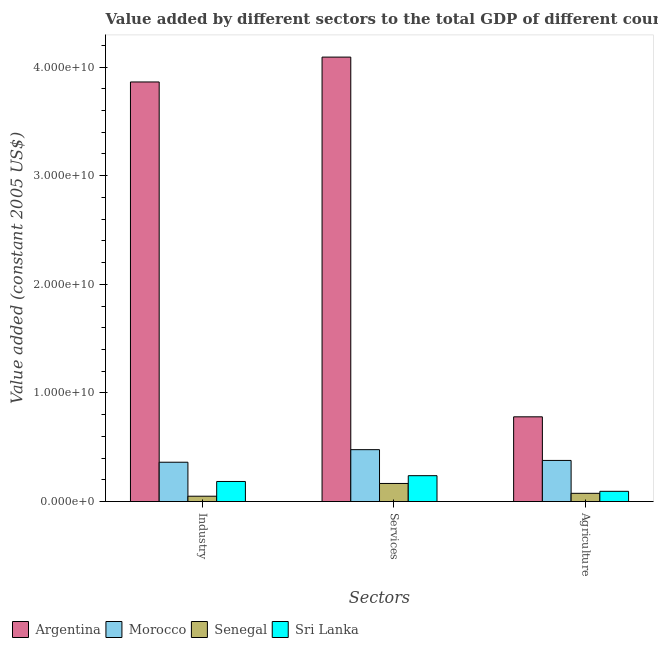What is the label of the 1st group of bars from the left?
Offer a very short reply. Industry. What is the value added by services in Senegal?
Give a very brief answer. 1.67e+09. Across all countries, what is the maximum value added by agricultural sector?
Your response must be concise. 7.80e+09. Across all countries, what is the minimum value added by agricultural sector?
Your answer should be very brief. 7.59e+08. In which country was the value added by agricultural sector minimum?
Provide a succinct answer. Senegal. What is the total value added by industrial sector in the graph?
Provide a succinct answer. 4.46e+1. What is the difference between the value added by industrial sector in Senegal and that in Sri Lanka?
Give a very brief answer. -1.36e+09. What is the difference between the value added by services in Argentina and the value added by agricultural sector in Morocco?
Ensure brevity in your answer.  3.71e+1. What is the average value added by industrial sector per country?
Provide a succinct answer. 1.11e+1. What is the difference between the value added by industrial sector and value added by agricultural sector in Morocco?
Offer a very short reply. -1.65e+08. In how many countries, is the value added by services greater than 18000000000 US$?
Your response must be concise. 1. What is the ratio of the value added by services in Senegal to that in Morocco?
Ensure brevity in your answer.  0.35. Is the value added by services in Morocco less than that in Argentina?
Your answer should be very brief. Yes. What is the difference between the highest and the second highest value added by industrial sector?
Your answer should be very brief. 3.50e+1. What is the difference between the highest and the lowest value added by agricultural sector?
Your response must be concise. 7.04e+09. In how many countries, is the value added by agricultural sector greater than the average value added by agricultural sector taken over all countries?
Ensure brevity in your answer.  2. Is the sum of the value added by industrial sector in Morocco and Sri Lanka greater than the maximum value added by agricultural sector across all countries?
Ensure brevity in your answer.  No. What does the 2nd bar from the left in Industry represents?
Make the answer very short. Morocco. What does the 3rd bar from the right in Agriculture represents?
Provide a short and direct response. Morocco. Is it the case that in every country, the sum of the value added by industrial sector and value added by services is greater than the value added by agricultural sector?
Give a very brief answer. Yes. Are all the bars in the graph horizontal?
Your answer should be very brief. No. How many countries are there in the graph?
Your answer should be compact. 4. What is the difference between two consecutive major ticks on the Y-axis?
Your response must be concise. 1.00e+1. Does the graph contain any zero values?
Ensure brevity in your answer.  No. How many legend labels are there?
Offer a terse response. 4. How are the legend labels stacked?
Ensure brevity in your answer.  Horizontal. What is the title of the graph?
Provide a succinct answer. Value added by different sectors to the total GDP of different countries. What is the label or title of the X-axis?
Offer a very short reply. Sectors. What is the label or title of the Y-axis?
Provide a succinct answer. Value added (constant 2005 US$). What is the Value added (constant 2005 US$) in Argentina in Industry?
Your answer should be very brief. 3.86e+1. What is the Value added (constant 2005 US$) of Morocco in Industry?
Make the answer very short. 3.62e+09. What is the Value added (constant 2005 US$) of Senegal in Industry?
Offer a very short reply. 4.93e+08. What is the Value added (constant 2005 US$) in Sri Lanka in Industry?
Your answer should be very brief. 1.85e+09. What is the Value added (constant 2005 US$) of Argentina in Services?
Provide a short and direct response. 4.09e+1. What is the Value added (constant 2005 US$) in Morocco in Services?
Make the answer very short. 4.78e+09. What is the Value added (constant 2005 US$) in Senegal in Services?
Make the answer very short. 1.67e+09. What is the Value added (constant 2005 US$) of Sri Lanka in Services?
Your answer should be very brief. 2.38e+09. What is the Value added (constant 2005 US$) of Argentina in Agriculture?
Offer a terse response. 7.80e+09. What is the Value added (constant 2005 US$) of Morocco in Agriculture?
Offer a terse response. 3.79e+09. What is the Value added (constant 2005 US$) of Senegal in Agriculture?
Provide a short and direct response. 7.59e+08. What is the Value added (constant 2005 US$) of Sri Lanka in Agriculture?
Make the answer very short. 9.42e+08. Across all Sectors, what is the maximum Value added (constant 2005 US$) in Argentina?
Provide a succinct answer. 4.09e+1. Across all Sectors, what is the maximum Value added (constant 2005 US$) of Morocco?
Provide a short and direct response. 4.78e+09. Across all Sectors, what is the maximum Value added (constant 2005 US$) in Senegal?
Ensure brevity in your answer.  1.67e+09. Across all Sectors, what is the maximum Value added (constant 2005 US$) in Sri Lanka?
Provide a short and direct response. 2.38e+09. Across all Sectors, what is the minimum Value added (constant 2005 US$) of Argentina?
Offer a terse response. 7.80e+09. Across all Sectors, what is the minimum Value added (constant 2005 US$) in Morocco?
Offer a very short reply. 3.62e+09. Across all Sectors, what is the minimum Value added (constant 2005 US$) of Senegal?
Ensure brevity in your answer.  4.93e+08. Across all Sectors, what is the minimum Value added (constant 2005 US$) in Sri Lanka?
Keep it short and to the point. 9.42e+08. What is the total Value added (constant 2005 US$) of Argentina in the graph?
Your answer should be compact. 8.74e+1. What is the total Value added (constant 2005 US$) in Morocco in the graph?
Ensure brevity in your answer.  1.22e+1. What is the total Value added (constant 2005 US$) of Senegal in the graph?
Ensure brevity in your answer.  2.92e+09. What is the total Value added (constant 2005 US$) of Sri Lanka in the graph?
Keep it short and to the point. 5.18e+09. What is the difference between the Value added (constant 2005 US$) of Argentina in Industry and that in Services?
Your answer should be very brief. -2.29e+09. What is the difference between the Value added (constant 2005 US$) in Morocco in Industry and that in Services?
Ensure brevity in your answer.  -1.16e+09. What is the difference between the Value added (constant 2005 US$) of Senegal in Industry and that in Services?
Your answer should be compact. -1.17e+09. What is the difference between the Value added (constant 2005 US$) of Sri Lanka in Industry and that in Services?
Ensure brevity in your answer.  -5.33e+08. What is the difference between the Value added (constant 2005 US$) in Argentina in Industry and that in Agriculture?
Make the answer very short. 3.08e+1. What is the difference between the Value added (constant 2005 US$) in Morocco in Industry and that in Agriculture?
Ensure brevity in your answer.  -1.65e+08. What is the difference between the Value added (constant 2005 US$) of Senegal in Industry and that in Agriculture?
Your answer should be compact. -2.66e+08. What is the difference between the Value added (constant 2005 US$) in Sri Lanka in Industry and that in Agriculture?
Give a very brief answer. 9.07e+08. What is the difference between the Value added (constant 2005 US$) of Argentina in Services and that in Agriculture?
Your response must be concise. 3.31e+1. What is the difference between the Value added (constant 2005 US$) in Morocco in Services and that in Agriculture?
Provide a short and direct response. 9.91e+08. What is the difference between the Value added (constant 2005 US$) of Senegal in Services and that in Agriculture?
Keep it short and to the point. 9.08e+08. What is the difference between the Value added (constant 2005 US$) in Sri Lanka in Services and that in Agriculture?
Provide a short and direct response. 1.44e+09. What is the difference between the Value added (constant 2005 US$) in Argentina in Industry and the Value added (constant 2005 US$) in Morocco in Services?
Provide a short and direct response. 3.39e+1. What is the difference between the Value added (constant 2005 US$) in Argentina in Industry and the Value added (constant 2005 US$) in Senegal in Services?
Give a very brief answer. 3.70e+1. What is the difference between the Value added (constant 2005 US$) of Argentina in Industry and the Value added (constant 2005 US$) of Sri Lanka in Services?
Make the answer very short. 3.62e+1. What is the difference between the Value added (constant 2005 US$) in Morocco in Industry and the Value added (constant 2005 US$) in Senegal in Services?
Make the answer very short. 1.95e+09. What is the difference between the Value added (constant 2005 US$) of Morocco in Industry and the Value added (constant 2005 US$) of Sri Lanka in Services?
Provide a short and direct response. 1.24e+09. What is the difference between the Value added (constant 2005 US$) of Senegal in Industry and the Value added (constant 2005 US$) of Sri Lanka in Services?
Your response must be concise. -1.89e+09. What is the difference between the Value added (constant 2005 US$) in Argentina in Industry and the Value added (constant 2005 US$) in Morocco in Agriculture?
Offer a terse response. 3.48e+1. What is the difference between the Value added (constant 2005 US$) of Argentina in Industry and the Value added (constant 2005 US$) of Senegal in Agriculture?
Offer a very short reply. 3.79e+1. What is the difference between the Value added (constant 2005 US$) of Argentina in Industry and the Value added (constant 2005 US$) of Sri Lanka in Agriculture?
Offer a very short reply. 3.77e+1. What is the difference between the Value added (constant 2005 US$) of Morocco in Industry and the Value added (constant 2005 US$) of Senegal in Agriculture?
Provide a short and direct response. 2.86e+09. What is the difference between the Value added (constant 2005 US$) of Morocco in Industry and the Value added (constant 2005 US$) of Sri Lanka in Agriculture?
Give a very brief answer. 2.68e+09. What is the difference between the Value added (constant 2005 US$) of Senegal in Industry and the Value added (constant 2005 US$) of Sri Lanka in Agriculture?
Give a very brief answer. -4.49e+08. What is the difference between the Value added (constant 2005 US$) of Argentina in Services and the Value added (constant 2005 US$) of Morocco in Agriculture?
Keep it short and to the point. 3.71e+1. What is the difference between the Value added (constant 2005 US$) in Argentina in Services and the Value added (constant 2005 US$) in Senegal in Agriculture?
Provide a short and direct response. 4.02e+1. What is the difference between the Value added (constant 2005 US$) of Argentina in Services and the Value added (constant 2005 US$) of Sri Lanka in Agriculture?
Make the answer very short. 4.00e+1. What is the difference between the Value added (constant 2005 US$) in Morocco in Services and the Value added (constant 2005 US$) in Senegal in Agriculture?
Offer a terse response. 4.02e+09. What is the difference between the Value added (constant 2005 US$) of Morocco in Services and the Value added (constant 2005 US$) of Sri Lanka in Agriculture?
Provide a succinct answer. 3.84e+09. What is the difference between the Value added (constant 2005 US$) of Senegal in Services and the Value added (constant 2005 US$) of Sri Lanka in Agriculture?
Provide a short and direct response. 7.25e+08. What is the average Value added (constant 2005 US$) of Argentina per Sectors?
Make the answer very short. 2.91e+1. What is the average Value added (constant 2005 US$) of Morocco per Sectors?
Your answer should be very brief. 4.06e+09. What is the average Value added (constant 2005 US$) of Senegal per Sectors?
Your response must be concise. 9.73e+08. What is the average Value added (constant 2005 US$) of Sri Lanka per Sectors?
Make the answer very short. 1.73e+09. What is the difference between the Value added (constant 2005 US$) in Argentina and Value added (constant 2005 US$) in Morocco in Industry?
Your response must be concise. 3.50e+1. What is the difference between the Value added (constant 2005 US$) of Argentina and Value added (constant 2005 US$) of Senegal in Industry?
Provide a succinct answer. 3.81e+1. What is the difference between the Value added (constant 2005 US$) in Argentina and Value added (constant 2005 US$) in Sri Lanka in Industry?
Your response must be concise. 3.68e+1. What is the difference between the Value added (constant 2005 US$) in Morocco and Value added (constant 2005 US$) in Senegal in Industry?
Your answer should be compact. 3.13e+09. What is the difference between the Value added (constant 2005 US$) of Morocco and Value added (constant 2005 US$) of Sri Lanka in Industry?
Make the answer very short. 1.77e+09. What is the difference between the Value added (constant 2005 US$) of Senegal and Value added (constant 2005 US$) of Sri Lanka in Industry?
Provide a short and direct response. -1.36e+09. What is the difference between the Value added (constant 2005 US$) of Argentina and Value added (constant 2005 US$) of Morocco in Services?
Offer a terse response. 3.61e+1. What is the difference between the Value added (constant 2005 US$) of Argentina and Value added (constant 2005 US$) of Senegal in Services?
Your answer should be compact. 3.93e+1. What is the difference between the Value added (constant 2005 US$) of Argentina and Value added (constant 2005 US$) of Sri Lanka in Services?
Provide a short and direct response. 3.85e+1. What is the difference between the Value added (constant 2005 US$) of Morocco and Value added (constant 2005 US$) of Senegal in Services?
Ensure brevity in your answer.  3.11e+09. What is the difference between the Value added (constant 2005 US$) of Morocco and Value added (constant 2005 US$) of Sri Lanka in Services?
Make the answer very short. 2.40e+09. What is the difference between the Value added (constant 2005 US$) in Senegal and Value added (constant 2005 US$) in Sri Lanka in Services?
Keep it short and to the point. -7.16e+08. What is the difference between the Value added (constant 2005 US$) of Argentina and Value added (constant 2005 US$) of Morocco in Agriculture?
Give a very brief answer. 4.02e+09. What is the difference between the Value added (constant 2005 US$) in Argentina and Value added (constant 2005 US$) in Senegal in Agriculture?
Your response must be concise. 7.04e+09. What is the difference between the Value added (constant 2005 US$) of Argentina and Value added (constant 2005 US$) of Sri Lanka in Agriculture?
Make the answer very short. 6.86e+09. What is the difference between the Value added (constant 2005 US$) in Morocco and Value added (constant 2005 US$) in Senegal in Agriculture?
Give a very brief answer. 3.03e+09. What is the difference between the Value added (constant 2005 US$) in Morocco and Value added (constant 2005 US$) in Sri Lanka in Agriculture?
Provide a succinct answer. 2.84e+09. What is the difference between the Value added (constant 2005 US$) in Senegal and Value added (constant 2005 US$) in Sri Lanka in Agriculture?
Offer a very short reply. -1.84e+08. What is the ratio of the Value added (constant 2005 US$) in Argentina in Industry to that in Services?
Your response must be concise. 0.94. What is the ratio of the Value added (constant 2005 US$) of Morocco in Industry to that in Services?
Make the answer very short. 0.76. What is the ratio of the Value added (constant 2005 US$) in Senegal in Industry to that in Services?
Your answer should be compact. 0.3. What is the ratio of the Value added (constant 2005 US$) in Sri Lanka in Industry to that in Services?
Keep it short and to the point. 0.78. What is the ratio of the Value added (constant 2005 US$) of Argentina in Industry to that in Agriculture?
Your response must be concise. 4.95. What is the ratio of the Value added (constant 2005 US$) of Morocco in Industry to that in Agriculture?
Provide a short and direct response. 0.96. What is the ratio of the Value added (constant 2005 US$) of Senegal in Industry to that in Agriculture?
Ensure brevity in your answer.  0.65. What is the ratio of the Value added (constant 2005 US$) in Sri Lanka in Industry to that in Agriculture?
Ensure brevity in your answer.  1.96. What is the ratio of the Value added (constant 2005 US$) of Argentina in Services to that in Agriculture?
Offer a terse response. 5.24. What is the ratio of the Value added (constant 2005 US$) of Morocco in Services to that in Agriculture?
Provide a succinct answer. 1.26. What is the ratio of the Value added (constant 2005 US$) in Senegal in Services to that in Agriculture?
Your answer should be compact. 2.2. What is the ratio of the Value added (constant 2005 US$) in Sri Lanka in Services to that in Agriculture?
Your response must be concise. 2.53. What is the difference between the highest and the second highest Value added (constant 2005 US$) in Argentina?
Your response must be concise. 2.29e+09. What is the difference between the highest and the second highest Value added (constant 2005 US$) in Morocco?
Your answer should be very brief. 9.91e+08. What is the difference between the highest and the second highest Value added (constant 2005 US$) in Senegal?
Your answer should be compact. 9.08e+08. What is the difference between the highest and the second highest Value added (constant 2005 US$) of Sri Lanka?
Your answer should be very brief. 5.33e+08. What is the difference between the highest and the lowest Value added (constant 2005 US$) of Argentina?
Offer a very short reply. 3.31e+1. What is the difference between the highest and the lowest Value added (constant 2005 US$) of Morocco?
Your response must be concise. 1.16e+09. What is the difference between the highest and the lowest Value added (constant 2005 US$) of Senegal?
Offer a terse response. 1.17e+09. What is the difference between the highest and the lowest Value added (constant 2005 US$) of Sri Lanka?
Ensure brevity in your answer.  1.44e+09. 